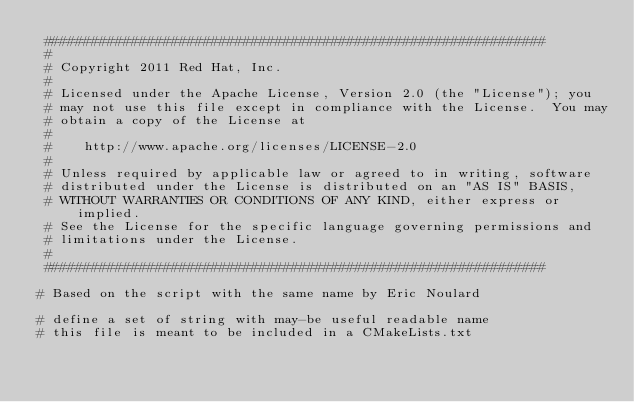<code> <loc_0><loc_0><loc_500><loc_500><_CMake_> ###############################################################
 # 
 # Copyright 2011 Red Hat, Inc. 
 # 
 # Licensed under the Apache License, Version 2.0 (the "License"); you 
 # may not use this file except in compliance with the License.  You may 
 # obtain a copy of the License at 
 # 
 #    http://www.apache.org/licenses/LICENSE-2.0 
 # 
 # Unless required by applicable law or agreed to in writing, software 
 # distributed under the License is distributed on an "AS IS" BASIS, 
 # WITHOUT WARRANTIES OR CONDITIONS OF ANY KIND, either express or implied.
 # See the License for the specific language governing permissions and 
 # limitations under the License. 
 # 
 ############################################################### 

# Based on the script with the same name by Eric Noulard 

# define a set of string with may-be useful readable name
# this file is meant to be included in a CMakeLists.txt</code> 